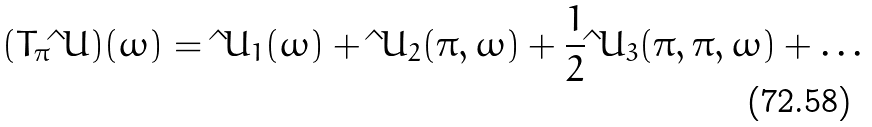Convert formula to latex. <formula><loc_0><loc_0><loc_500><loc_500>( T _ { \pi } \hat { \ } U ) ( \omega ) = \hat { \ } U _ { 1 } ( \omega ) + \hat { \ } U _ { 2 } ( \pi , \omega ) + \frac { 1 } { 2 } \hat { \ } U _ { 3 } ( \pi , \pi , \omega ) + \dots</formula> 